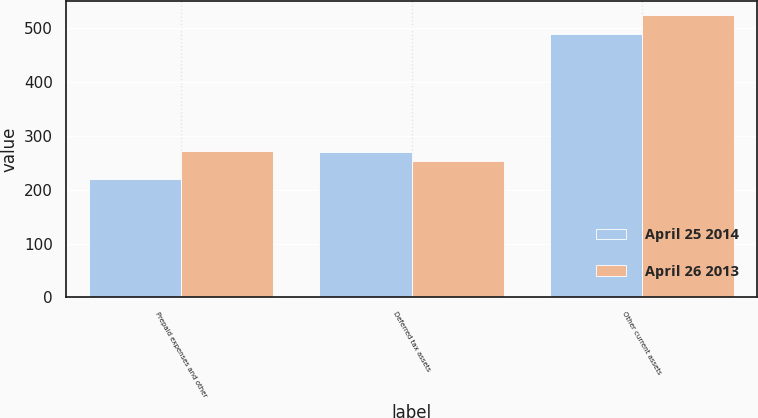Convert chart to OTSL. <chart><loc_0><loc_0><loc_500><loc_500><stacked_bar_chart><ecel><fcel>Prepaid expenses and other<fcel>Deferred tax assets<fcel>Other current assets<nl><fcel>April 25 2014<fcel>219.4<fcel>270.3<fcel>489.7<nl><fcel>April 26 2013<fcel>271.5<fcel>253.7<fcel>525.2<nl></chart> 